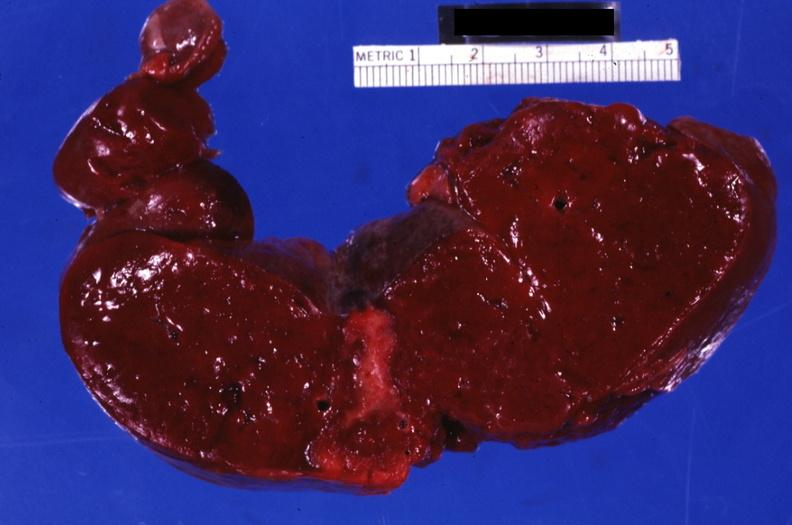s hematologic present?
Answer the question using a single word or phrase. Yes 